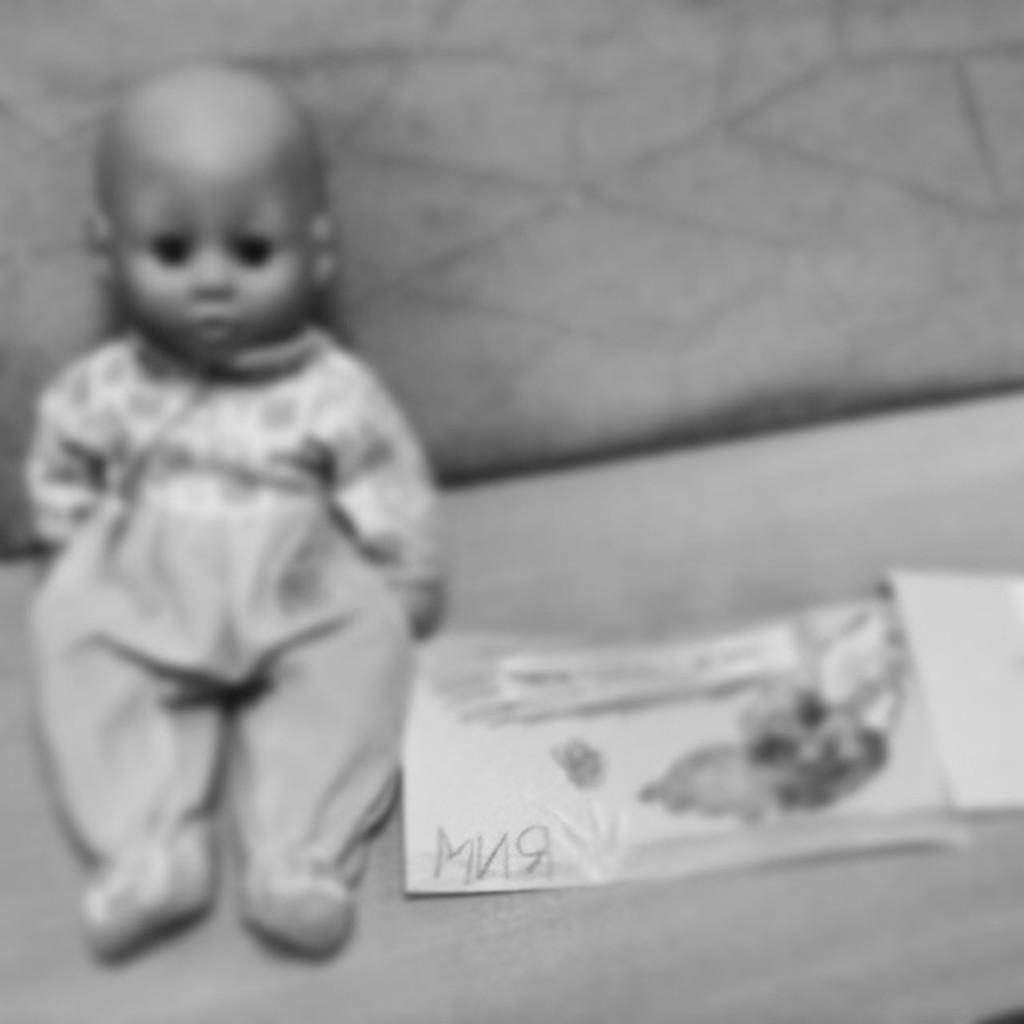What object can be seen in the image that is typically used for play? There is a toy in the image. What is present on the sofa in the image? Papers are on the sofa. What can be found on the papers? There is a text and a picture of a flower on the paper. Where is the bear sitting in the image? There is no bear present in the image. What type of food is being served in the lunchroom in the image? There is no lunchroom present in the image. 